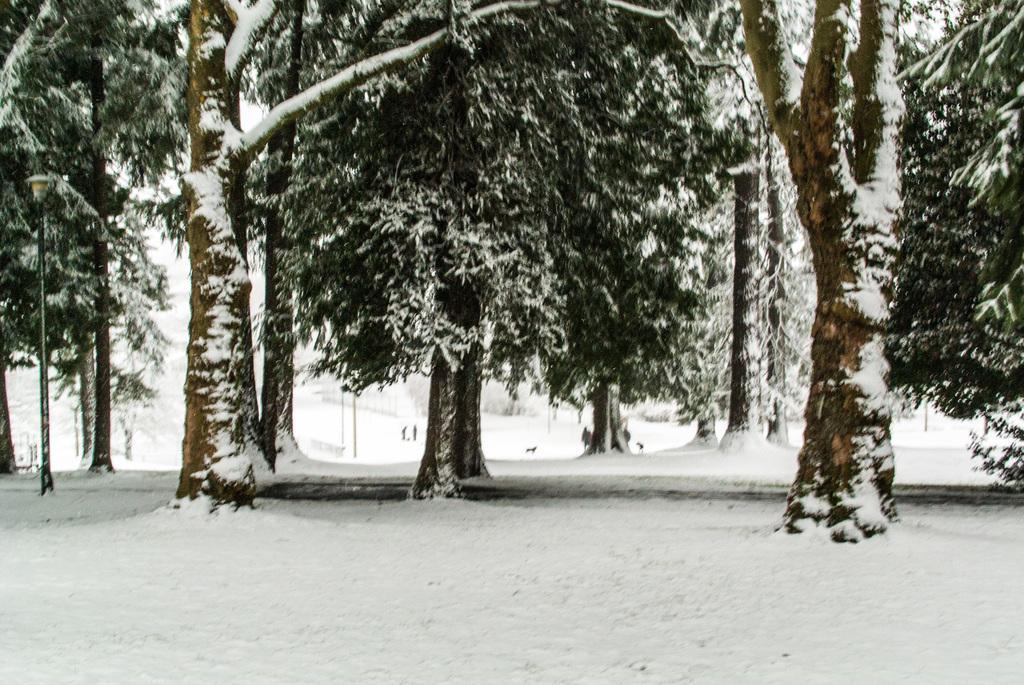How would you summarize this image in a sentence or two? In this image I see the white snow and in the background I see the trees on which there is snow and I see 2 persons over here. 